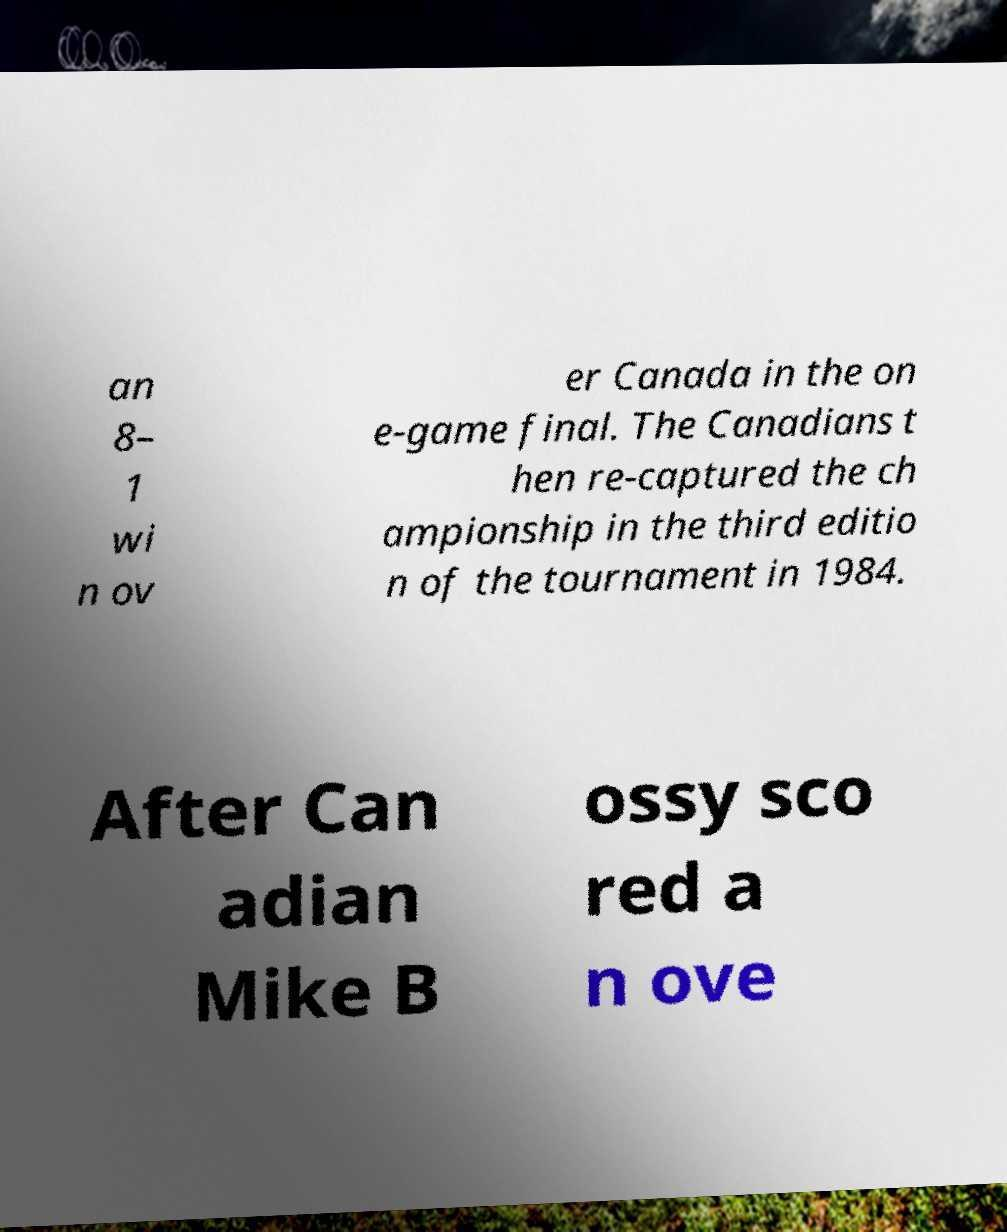Please identify and transcribe the text found in this image. an 8– 1 wi n ov er Canada in the on e-game final. The Canadians t hen re-captured the ch ampionship in the third editio n of the tournament in 1984. After Can adian Mike B ossy sco red a n ove 